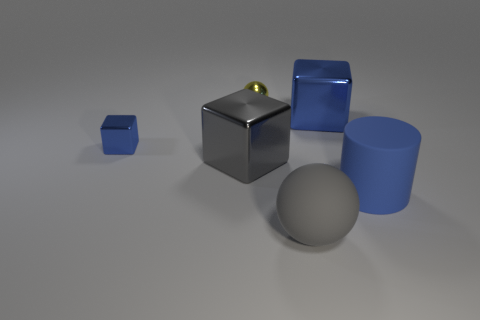Are there fewer large blue metal cubes behind the tiny yellow shiny object than large yellow rubber objects?
Your answer should be very brief. No. Is the yellow sphere made of the same material as the small blue block?
Give a very brief answer. Yes. The metallic object that is the same shape as the gray matte thing is what size?
Your answer should be compact. Small. What number of things are large gray things that are to the left of the tiny yellow metal object or gray things to the left of the big gray rubber object?
Make the answer very short. 1. Are there fewer small shiny balls than blue metal cubes?
Make the answer very short. Yes. There is a yellow ball; is it the same size as the gray thing that is behind the rubber cylinder?
Offer a very short reply. No. What number of metallic objects are large gray things or blue things?
Ensure brevity in your answer.  3. Are there more large blue rubber objects than tiny red metallic blocks?
Provide a succinct answer. Yes. There is a large matte thing that is on the right side of the matte thing in front of the blue rubber cylinder; what shape is it?
Keep it short and to the point. Cylinder. There is a big metallic cube in front of the metallic object to the left of the large gray block; are there any blue objects that are behind it?
Offer a terse response. Yes. 